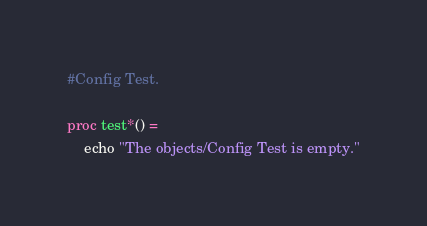<code> <loc_0><loc_0><loc_500><loc_500><_Nim_>#Config Test.

proc test*() =
    echo "The objects/Config Test is empty."
</code> 